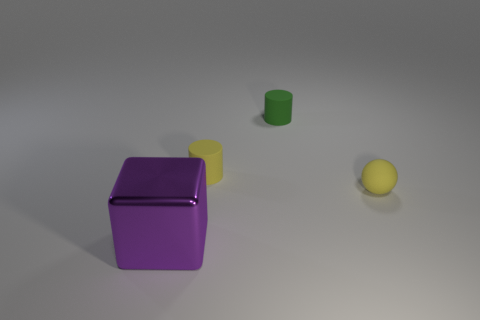Can you guess the purpose of this arrangement or scene? The arrangement of the objects does not seem to serve a functional purpose but might be part of a visual composition or a study of shapes and colors. It could be a simple setup designed to practice photographic skills, lighting techniques, or an illustrative example for a study on geometry and perspective in a three-dimensional space. 